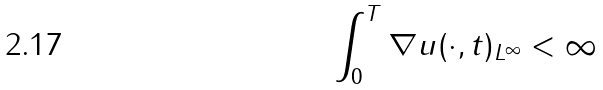<formula> <loc_0><loc_0><loc_500><loc_500>\int _ { 0 } ^ { T } \| \nabla u ( \cdot , t ) \| _ { L ^ { \infty } } < \infty</formula> 